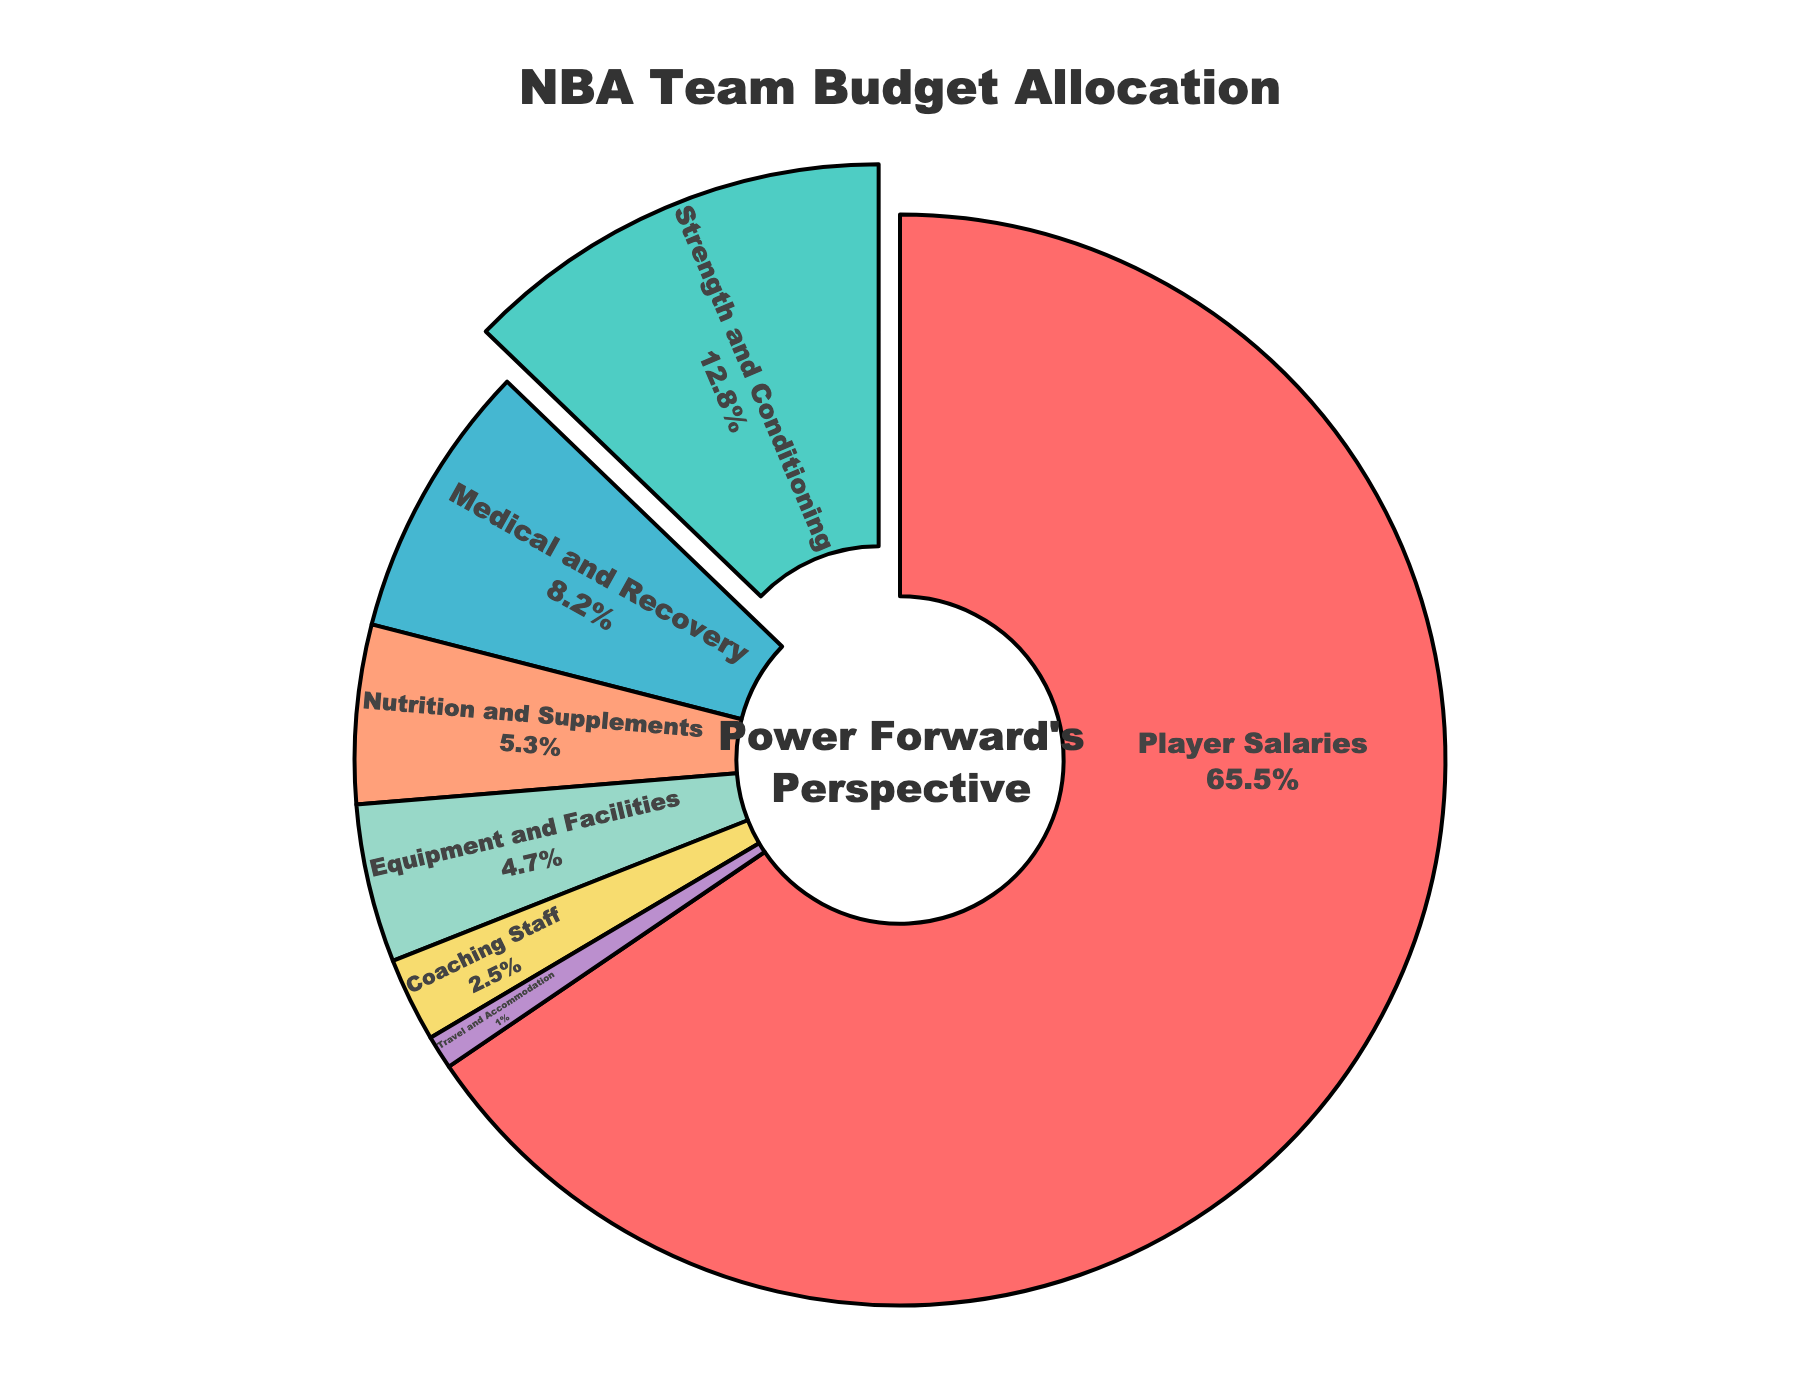Which category has the highest percentage allocation in the NBA team budget? By looking at the pie chart, you can see that "Player Salaries" has the largest section of the pie chart and is labeled with 65.5%.
Answer: Player Salaries What is the total percentage allocation for Strength and Conditioning, Medical and Recovery, and Nutrition and Supplements combined? Add the percentages for these three categories: 12.8% + 8.2% + 5.3% = 26.3%.
Answer: 26.3% How does the allocation for Strength and Conditioning compare to the allocation for Medical and Recovery? According to the pie chart, Strength and Conditioning is 12.8%, whereas Medical and Recovery is 8.2%, making the former greater than the latter.
Answer: Strength and Conditioning > Medical and Recovery Which category is highlighted or pulled out in the pie chart? The pie chart highlights and pulls out the section labeled "Strength and Conditioning".
Answer: Strength and Conditioning What percentage of the budget is allocated to categories other than Player Salaries? Subtract the percentage allocated to Player Salaries from 100%: 100% - 65.5% = 34.5%.
Answer: 34.5% How many categories have a budget allocation less than 10%? According to the pie chart, the categories with less than 10% are Medical and Recovery (8.2%), Nutrition and Supplements (5.3%), Equipment and Facilities (4.7%), Coaching Staff (2.5%), and Travel and Accommodation (1.0%). This amounts to five categories.
Answer: 5 What is the difference in percentage allocation between Equipment and Facilities, and Travel and Accommodation? The percentage allocation for Equipment and Facilities is 4.7%, and for Travel and Accommodation is 1.0%. The difference is 4.7% - 1.0% = 3.7%.
Answer: 3.7% Which two categories have the closest percentage allocations? Examine the pie chart for categories with similar percentages. Strength and Conditioning (12.8%) and Medical and Recovery (8.2%) are relatively close together compared to other pairs. However, Equipment and Facilities (4.7%) and Nutrition and Supplements (5.3%) are the closest pair with a difference of only 0.6%.
Answer: Equipment and Facilities and Nutrition and Supplements 